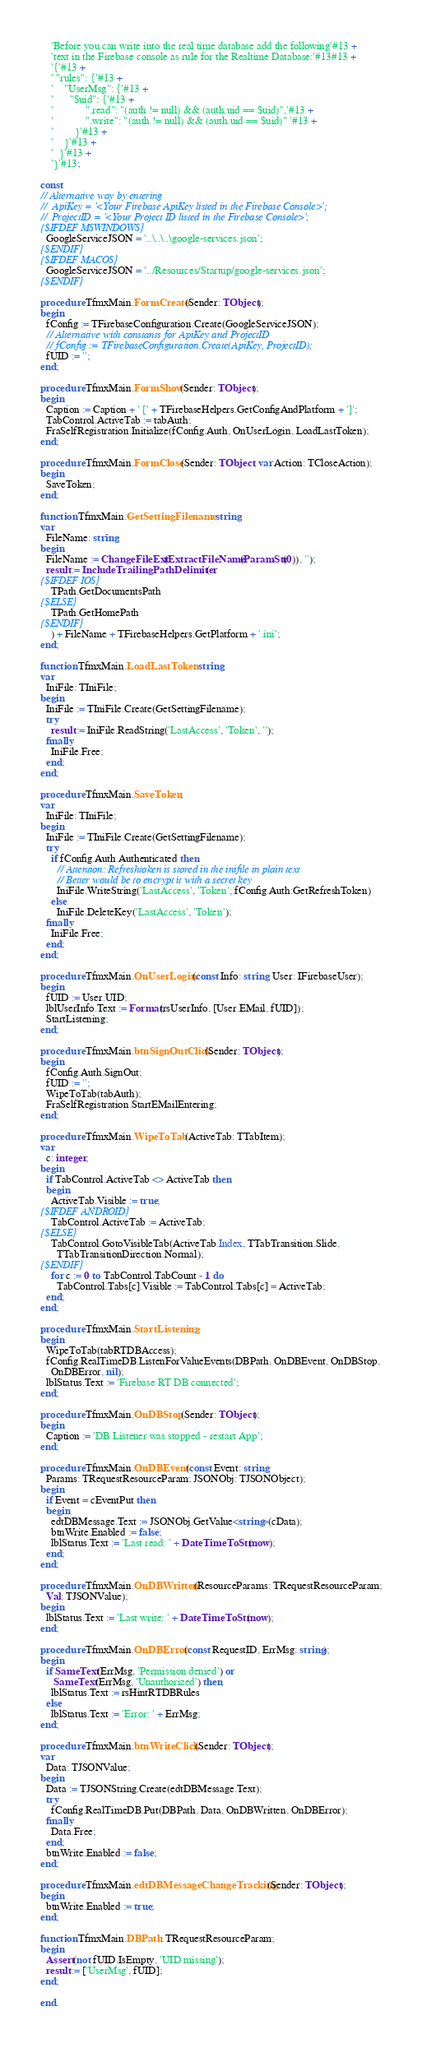<code> <loc_0><loc_0><loc_500><loc_500><_Pascal_>    'Before you can write into the real time database add the following'#13 +
    'text in the Firebase console as rule for the Realtime Database:'#13#13 +
    '{'#13 +
    ' "rules": {'#13 +
    '    "UserMsg": {'#13 +
    '      "$uid": {'#13 +
    '		    ".read": "(auth != null) && (auth.uid == $uid)",'#13 +
    '    		".write": "(auth != null) && (auth.uid == $uid)" '#13 +
    '    	}'#13 +
    '    }'#13 +
    '  }'#13 +
    '}'#13;

const
// Alternative way by entering
//  ApiKey = '<Your Firebase ApiKey listed in the Firebase Console>';
//  ProjectID = '<Your Project ID listed in the Firebase Console>';
{$IFDEF MSWINDOWS}
  GoogleServiceJSON = '..\..\..\google-services.json';
{$ENDIF}
{$IFDEF MACOS}
  GoogleServiceJSON = '../Resources/Startup/google-services.json';
{$ENDIF}

procedure TfmxMain.FormCreate(Sender: TObject);
begin
  fConfig := TFirebaseConfiguration.Create(GoogleServiceJSON);
  // Alternative with constants for ApiKey and ProjectID
  // fConfig := TFirebaseConfiguration.Create(ApiKey, ProjectID);
  fUID := '';
end;

procedure TfmxMain.FormShow(Sender: TObject);
begin
  Caption := Caption + ' [' + TFirebaseHelpers.GetConfigAndPlatform + ']';
  TabControl.ActiveTab := tabAuth;
  FraSelfRegistration.Initialize(fConfig.Auth, OnUserLogin, LoadLastToken);
end;

procedure TfmxMain.FormClose(Sender: TObject; var Action: TCloseAction);
begin
  SaveToken;
end;

function TfmxMain.GetSettingFilename: string;
var
  FileName: string;
begin
  FileName := ChangeFileExt(ExtractFileName(ParamStr(0)), '');
  result := IncludeTrailingPathDelimiter(
{$IFDEF IOS}
    TPath.GetDocumentsPath
{$ELSE}
    TPath.GetHomePath
{$ENDIF}
    ) + FileName + TFirebaseHelpers.GetPlatform + '.ini';
end;

function TfmxMain.LoadLastToken: string;
var
  IniFile: TIniFile;
begin
  IniFile := TIniFile.Create(GetSettingFilename);
  try
    result := IniFile.ReadString('LastAccess', 'Token', '');
  finally
    IniFile.Free;
  end;
end;

procedure TfmxMain.SaveToken;
var
  IniFile: TIniFile;
begin
  IniFile := TIniFile.Create(GetSettingFilename);
  try
    if fConfig.Auth.Authenticated then
      // Attention: Refreshtoken is stored in the inifile in plain text
      // Better would be to encrypt it with a secret key
      IniFile.WriteString('LastAccess', 'Token', fConfig.Auth.GetRefreshToken)
    else
      IniFile.DeleteKey('LastAccess', 'Token');
  finally
    IniFile.Free;
  end;
end;

procedure TfmxMain.OnUserLogin(const Info: string; User: IFirebaseUser);
begin
  fUID := User.UID;
  lblUserInfo.Text := Format(rsUserInfo, [User.EMail, fUID]);
  StartListening;
end;

procedure TfmxMain.btnSignOutClick(Sender: TObject);
begin
  fConfig.Auth.SignOut;
  fUID := '';
  WipeToTab(tabAuth);
  FraSelfRegistration.StartEMailEntering;
end;

procedure TfmxMain.WipeToTab(ActiveTab: TTabItem);
var
  c: integer;
begin
  if TabControl.ActiveTab <> ActiveTab then
  begin
    ActiveTab.Visible := true;
{$IFDEF ANDROID}
    TabControl.ActiveTab := ActiveTab;
{$ELSE}
    TabControl.GotoVisibleTab(ActiveTab.Index, TTabTransition.Slide,
      TTabTransitionDirection.Normal);
{$ENDIF}
    for c := 0 to TabControl.TabCount - 1 do
      TabControl.Tabs[c].Visible := TabControl.Tabs[c] = ActiveTab;
  end;
end;

procedure TfmxMain.StartListening;
begin
  WipeToTab(tabRTDBAccess);
  fConfig.RealTimeDB.ListenForValueEvents(DBPath, OnDBEvent, OnDBStop,
    OnDBError, nil);
  lblStatus.Text := 'Firebase RT DB connected';
end;

procedure TfmxMain.OnDBStop(Sender: TObject);
begin
  Caption := 'DB Listener was stopped - restart App';
end;

procedure TfmxMain.OnDBEvent(const Event: string;
  Params: TRequestResourceParam; JSONObj: TJSONObject);
begin
  if Event = cEventPut then
  begin
    edtDBMessage.Text := JSONObj.GetValue<string>(cData);
    btnWrite.Enabled := false;
    lblStatus.Text := 'Last read: ' + DateTimeToStr(now);
  end;
end;

procedure TfmxMain.OnDBWritten(ResourceParams: TRequestResourceParam;
  Val: TJSONValue);
begin
  lblStatus.Text := 'Last write: ' + DateTimeToStr(now);
end;

procedure TfmxMain.OnDBError(const RequestID, ErrMsg: string);
begin
  if SameText(ErrMsg, 'Permission denied') or
     SameText(ErrMsg, 'Unauthorized') then
    lblStatus.Text := rsHintRTDBRules
  else
    lblStatus.Text := 'Error: ' + ErrMsg;
end;

procedure TfmxMain.btnWriteClick(Sender: TObject);
var
  Data: TJSONValue;
begin
  Data := TJSONString.Create(edtDBMessage.Text);
  try
    fConfig.RealTimeDB.Put(DBPath, Data, OnDBWritten, OnDBError);
  finally
    Data.Free;
  end;
  btnWrite.Enabled := false;
end;

procedure TfmxMain.edtDBMessageChangeTracking(Sender: TObject);
begin
  btnWrite.Enabled := true;
end;

function TfmxMain.DBPath: TRequestResourceParam;
begin
  Assert(not fUID.IsEmpty, 'UID missing');
  result := ['UserMsg', fUID];
end;

end.
</code> 